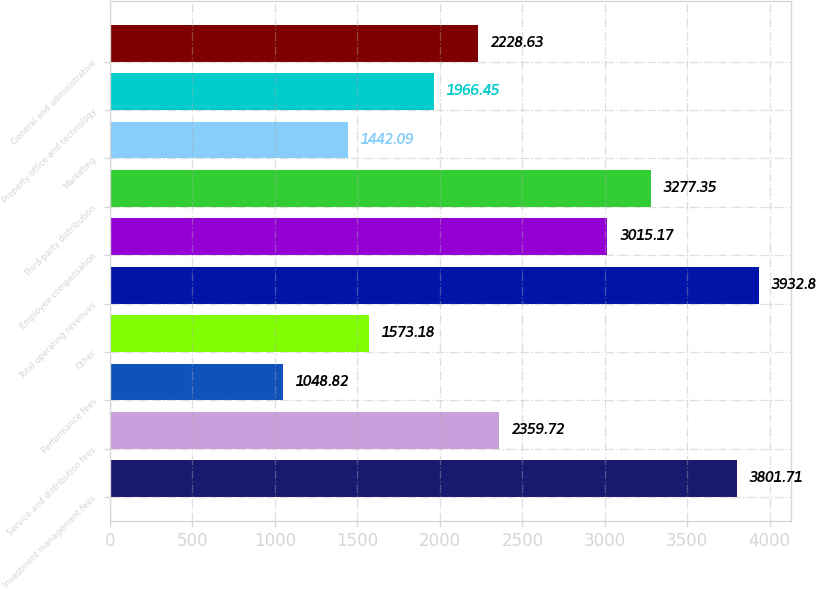Convert chart to OTSL. <chart><loc_0><loc_0><loc_500><loc_500><bar_chart><fcel>Investment management fees<fcel>Service and distribution fees<fcel>Performance fees<fcel>Other<fcel>Total operating revenues<fcel>Employee compensation<fcel>Third-party distribution<fcel>Marketing<fcel>Property office and technology<fcel>General and administrative<nl><fcel>3801.71<fcel>2359.72<fcel>1048.82<fcel>1573.18<fcel>3932.8<fcel>3015.17<fcel>3277.35<fcel>1442.09<fcel>1966.45<fcel>2228.63<nl></chart> 